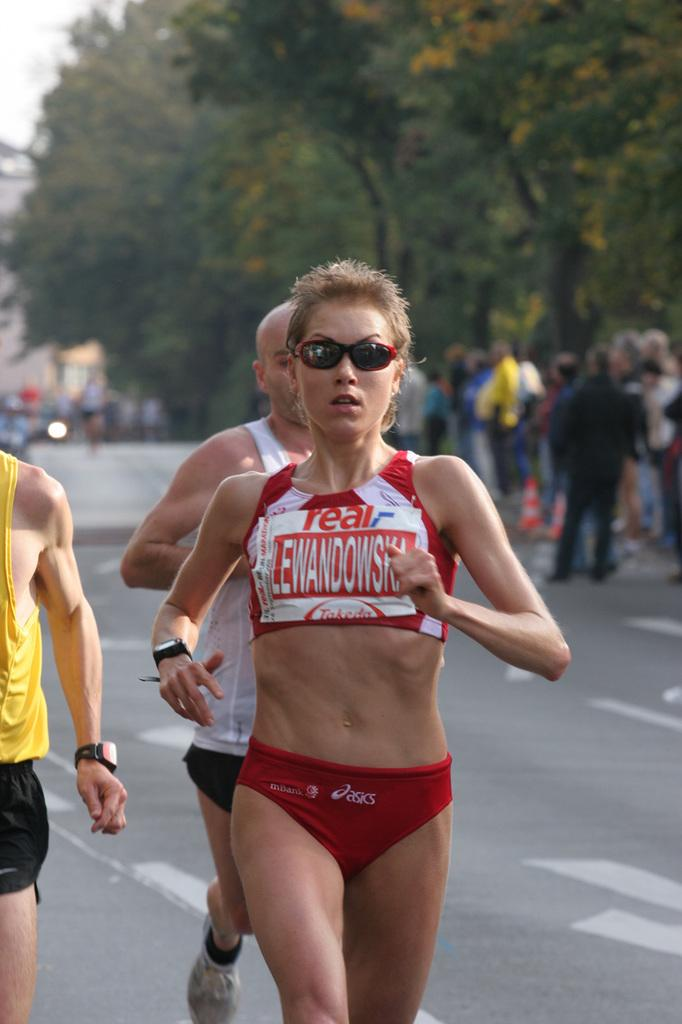<image>
Describe the image concisely. A runner in a pair of asics shorts wears sunglasses and a watch. 